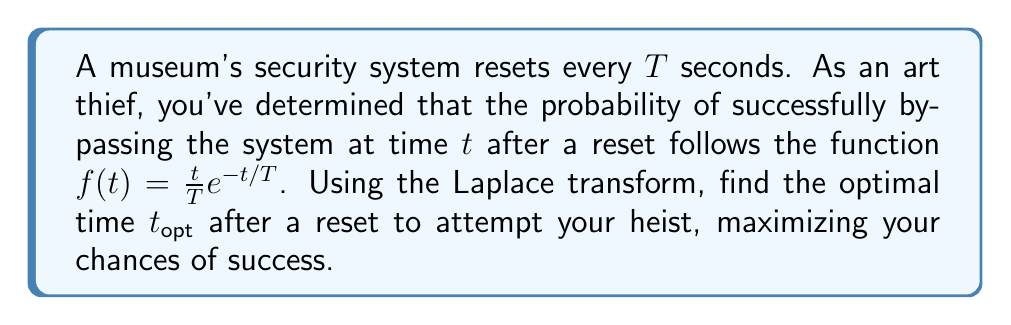Can you solve this math problem? To solve this problem, we'll follow these steps:

1) First, we need to find the Laplace transform of $f(t)$.
2) Then, we'll use the property that the maximum of $f(t)$ occurs when its derivative $f'(t)$ is zero.
3) We'll use the Laplace transform to find $f'(t)$.
4) Finally, we'll solve for $t_{opt}$ when $f'(t) = 0$.

Step 1: Laplace transform of $f(t)$

Let $F(s)$ be the Laplace transform of $f(t)$. We have:

$$F(s) = \mathcal{L}\{f(t)\} = \mathcal{L}\{\frac{t}{T}e^{-t/T}\}$$

Using the property of Laplace transforms that $\mathcal{L}\{te^{-at}\} = \frac{1}{(s+a)^2}$, we get:

$$F(s) = \frac{1}{T} \cdot \frac{1}{(s+1/T)^2}$$

Step 2: Finding $f'(t)$

To find $f'(t)$, we can use the property that multiplication by $t$ in the time domain corresponds to $-\frac{d}{ds}$ in the s-domain. So:

$$sF(s) - f(0) = \mathcal{L}\{f'(t)\}$$

$$sF(s) = \frac{s}{T(s+1/T)^2}$$

$$\mathcal{L}\{f'(t)\} = \frac{s}{T(s+1/T)^2} - f(0)$$

Note that $f(0) = 0$, so:

$$\mathcal{L}\{f'(t)\} = \frac{s}{T(s+1/T)^2}$$

Step 3: Inverse Laplace transform to find $f'(t)$

Using partial fraction decomposition:

$$\frac{s}{T(s+1/T)^2} = \frac{1}{T} \cdot \frac{1}{s+1/T} - \frac{1}{T^2} \cdot \frac{1}{(s+1/T)^2}$$

Taking the inverse Laplace transform:

$$f'(t) = \frac{1}{T}e^{-t/T} - \frac{t}{T^2}e^{-t/T}$$

Step 4: Solving for $t_{opt}$

Set $f'(t) = 0$ and solve for $t$:

$$\frac{1}{T}e^{-t/T} - \frac{t}{T^2}e^{-t/T} = 0$$

$$1 - \frac{t}{T} = 0$$

$$t = T$$

Therefore, the optimal time to attempt the heist is $T$ seconds after a reset.
Answer: $t_{opt} = T$ 